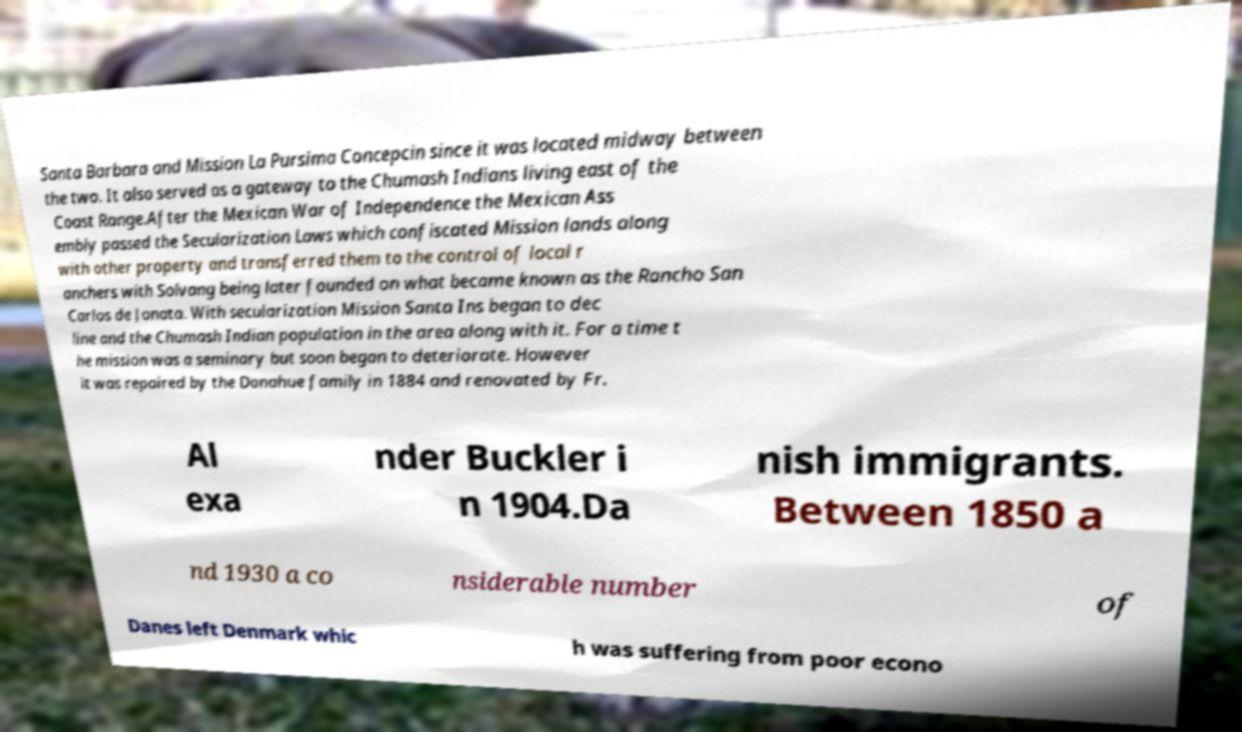I need the written content from this picture converted into text. Can you do that? Santa Barbara and Mission La Pursima Concepcin since it was located midway between the two. It also served as a gateway to the Chumash Indians living east of the Coast Range.After the Mexican War of Independence the Mexican Ass embly passed the Secularization Laws which confiscated Mission lands along with other property and transferred them to the control of local r anchers with Solvang being later founded on what became known as the Rancho San Carlos de Jonata. With secularization Mission Santa Ins began to dec line and the Chumash Indian population in the area along with it. For a time t he mission was a seminary but soon began to deteriorate. However it was repaired by the Donahue family in 1884 and renovated by Fr. Al exa nder Buckler i n 1904.Da nish immigrants. Between 1850 a nd 1930 a co nsiderable number of Danes left Denmark whic h was suffering from poor econo 